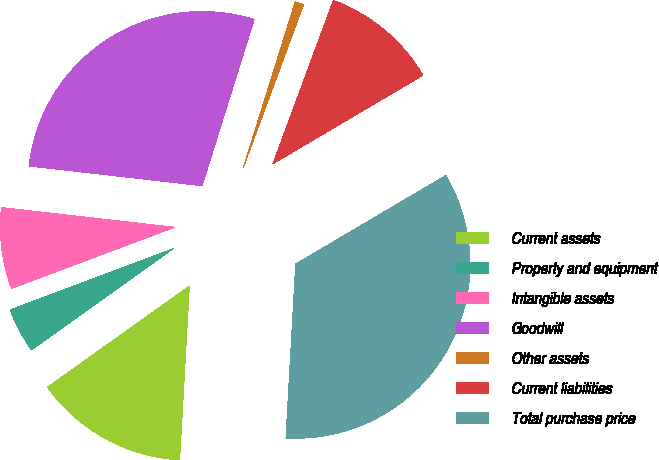<chart> <loc_0><loc_0><loc_500><loc_500><pie_chart><fcel>Current assets<fcel>Property and equipment<fcel>Intangible assets<fcel>Goodwill<fcel>Other assets<fcel>Current liabilities<fcel>Total purchase price<nl><fcel>14.24%<fcel>4.16%<fcel>7.52%<fcel>28.02%<fcel>0.81%<fcel>10.88%<fcel>34.38%<nl></chart> 